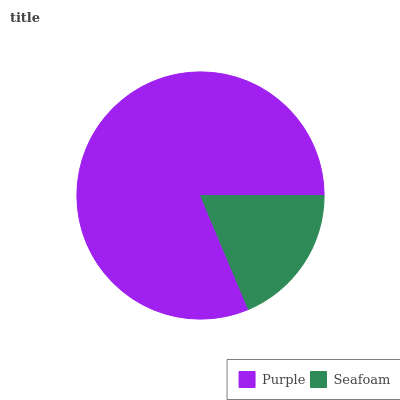Is Seafoam the minimum?
Answer yes or no. Yes. Is Purple the maximum?
Answer yes or no. Yes. Is Seafoam the maximum?
Answer yes or no. No. Is Purple greater than Seafoam?
Answer yes or no. Yes. Is Seafoam less than Purple?
Answer yes or no. Yes. Is Seafoam greater than Purple?
Answer yes or no. No. Is Purple less than Seafoam?
Answer yes or no. No. Is Purple the high median?
Answer yes or no. Yes. Is Seafoam the low median?
Answer yes or no. Yes. Is Seafoam the high median?
Answer yes or no. No. Is Purple the low median?
Answer yes or no. No. 